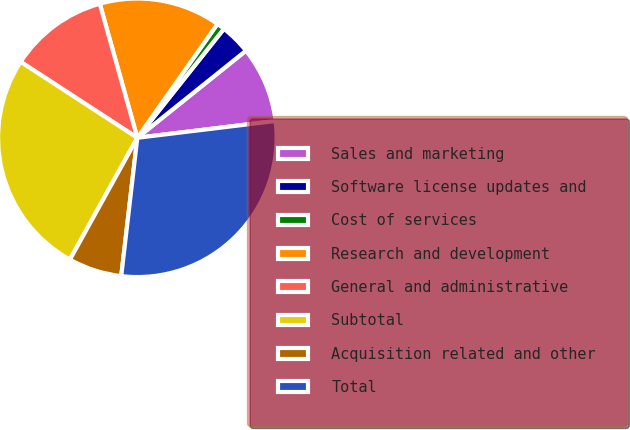Convert chart to OTSL. <chart><loc_0><loc_0><loc_500><loc_500><pie_chart><fcel>Sales and marketing<fcel>Software license updates and<fcel>Cost of services<fcel>Research and development<fcel>General and administrative<fcel>Subtotal<fcel>Acquisition related and other<fcel>Total<nl><fcel>8.83%<fcel>3.56%<fcel>0.92%<fcel>14.11%<fcel>11.47%<fcel>26.14%<fcel>6.2%<fcel>28.77%<nl></chart> 